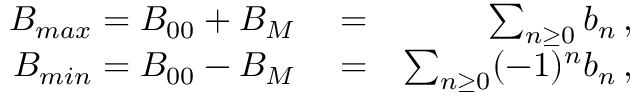<formula> <loc_0><loc_0><loc_500><loc_500>\begin{array} { r l r } { B _ { \max } = B _ { 0 0 } + B _ { M } } & = } & { \sum _ { n \geq 0 } b _ { n } \, , } \\ { B _ { \min } = B _ { 0 0 } - B _ { M } } & = } & { \sum _ { n \geq 0 } ( - 1 ) ^ { n } b _ { n } \, , } \end{array}</formula> 